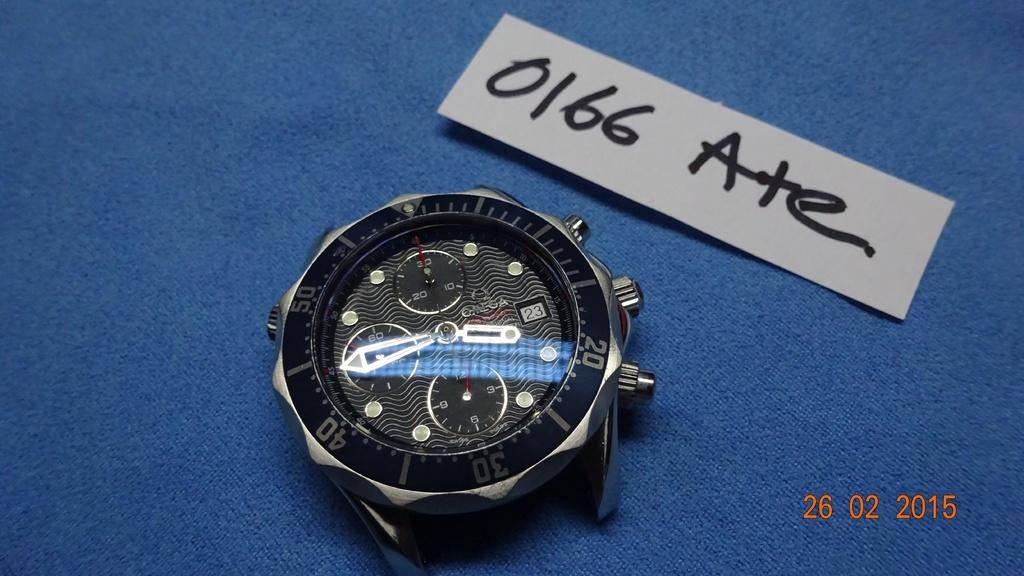<image>
Provide a brief description of the given image. A black and silver watch with a paper above it with 0166 Ate on it. 